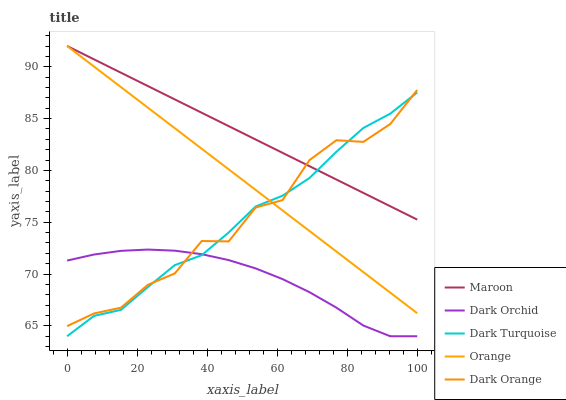Does Dark Orchid have the minimum area under the curve?
Answer yes or no. Yes. Does Maroon have the maximum area under the curve?
Answer yes or no. Yes. Does Dark Turquoise have the minimum area under the curve?
Answer yes or no. No. Does Dark Turquoise have the maximum area under the curve?
Answer yes or no. No. Is Maroon the smoothest?
Answer yes or no. Yes. Is Dark Orange the roughest?
Answer yes or no. Yes. Is Dark Turquoise the smoothest?
Answer yes or no. No. Is Dark Turquoise the roughest?
Answer yes or no. No. Does Dark Turquoise have the lowest value?
Answer yes or no. Yes. Does Maroon have the lowest value?
Answer yes or no. No. Does Maroon have the highest value?
Answer yes or no. Yes. Does Dark Turquoise have the highest value?
Answer yes or no. No. Is Dark Orchid less than Maroon?
Answer yes or no. Yes. Is Maroon greater than Dark Orchid?
Answer yes or no. Yes. Does Dark Orange intersect Dark Turquoise?
Answer yes or no. Yes. Is Dark Orange less than Dark Turquoise?
Answer yes or no. No. Is Dark Orange greater than Dark Turquoise?
Answer yes or no. No. Does Dark Orchid intersect Maroon?
Answer yes or no. No. 